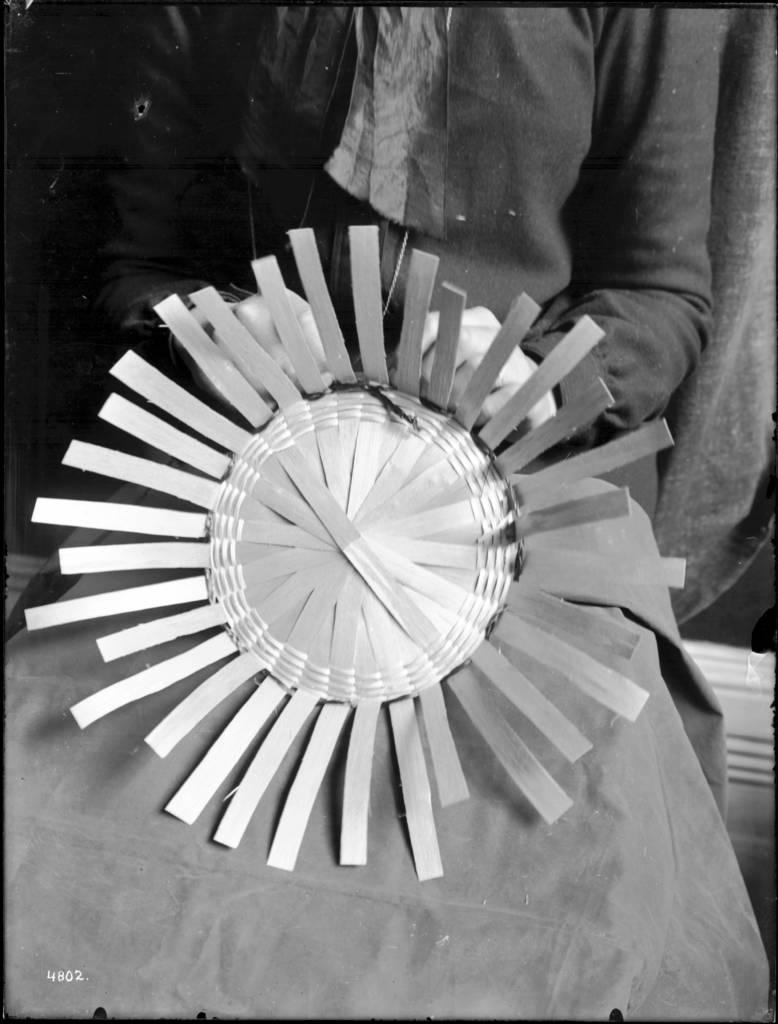What can be seen in the image? There is a person in the image. What is the person doing in the image? The person is holding an object. What type of paste is the person using to talk in the image? There is no paste or talking present in the image; it only shows a person holding an object. 